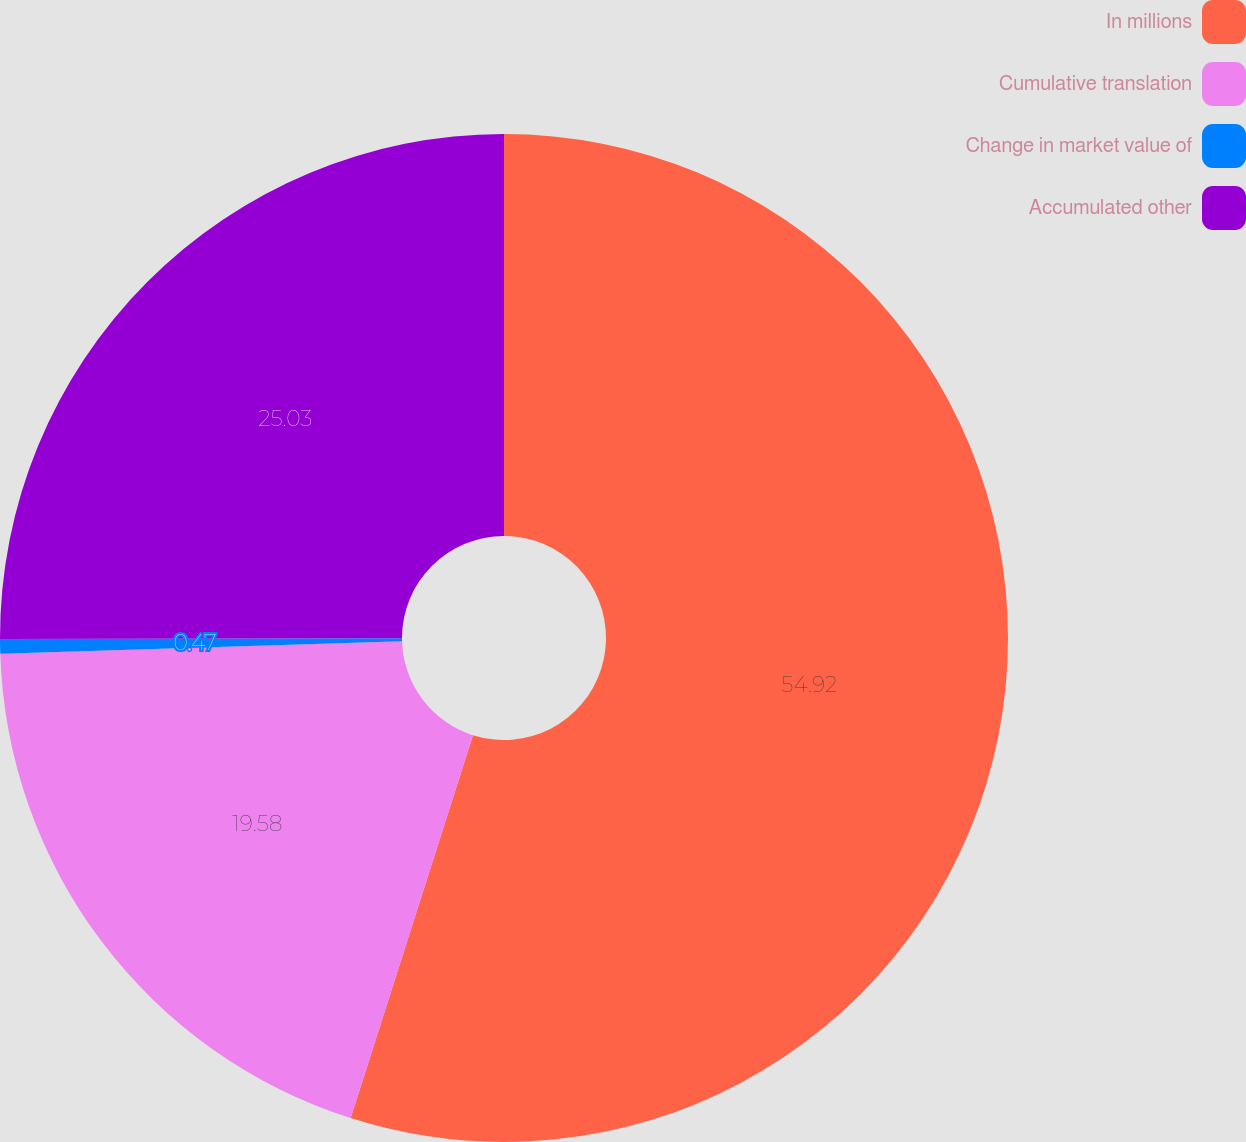Convert chart to OTSL. <chart><loc_0><loc_0><loc_500><loc_500><pie_chart><fcel>In millions<fcel>Cumulative translation<fcel>Change in market value of<fcel>Accumulated other<nl><fcel>54.92%<fcel>19.58%<fcel>0.47%<fcel>25.03%<nl></chart> 